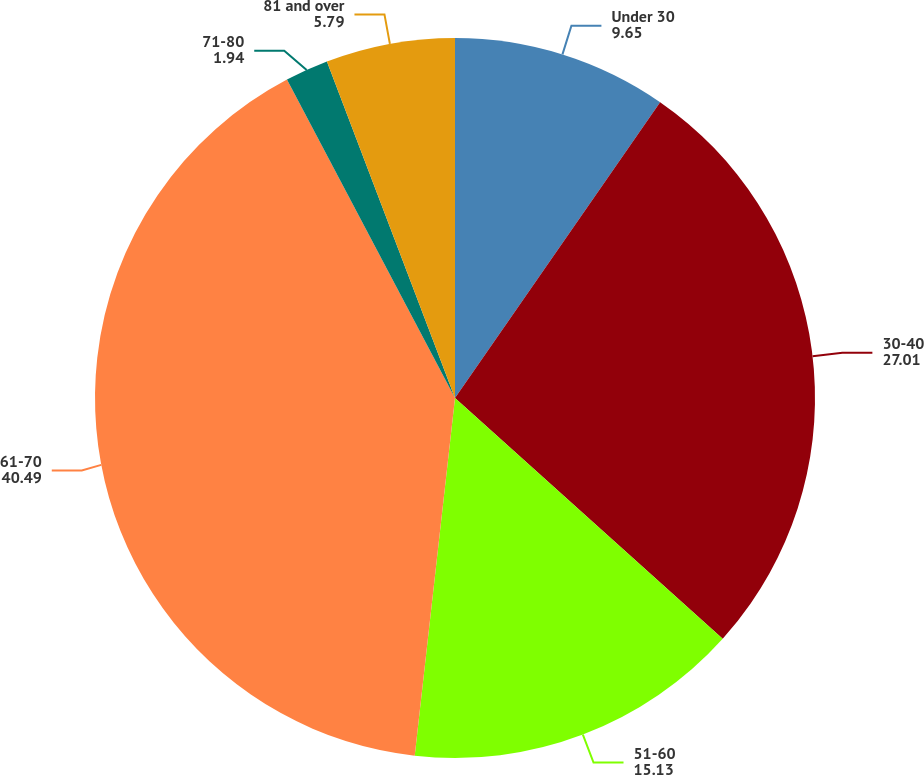<chart> <loc_0><loc_0><loc_500><loc_500><pie_chart><fcel>Under 30<fcel>30-40<fcel>51-60<fcel>61-70<fcel>71-80<fcel>81 and over<nl><fcel>9.65%<fcel>27.01%<fcel>15.13%<fcel>40.49%<fcel>1.94%<fcel>5.79%<nl></chart> 